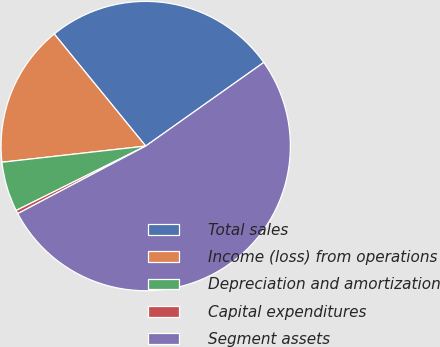Convert chart. <chart><loc_0><loc_0><loc_500><loc_500><pie_chart><fcel>Total sales<fcel>Income (loss) from operations<fcel>Depreciation and amortization<fcel>Capital expenditures<fcel>Segment assets<nl><fcel>26.09%<fcel>15.89%<fcel>5.56%<fcel>0.39%<fcel>52.07%<nl></chart> 